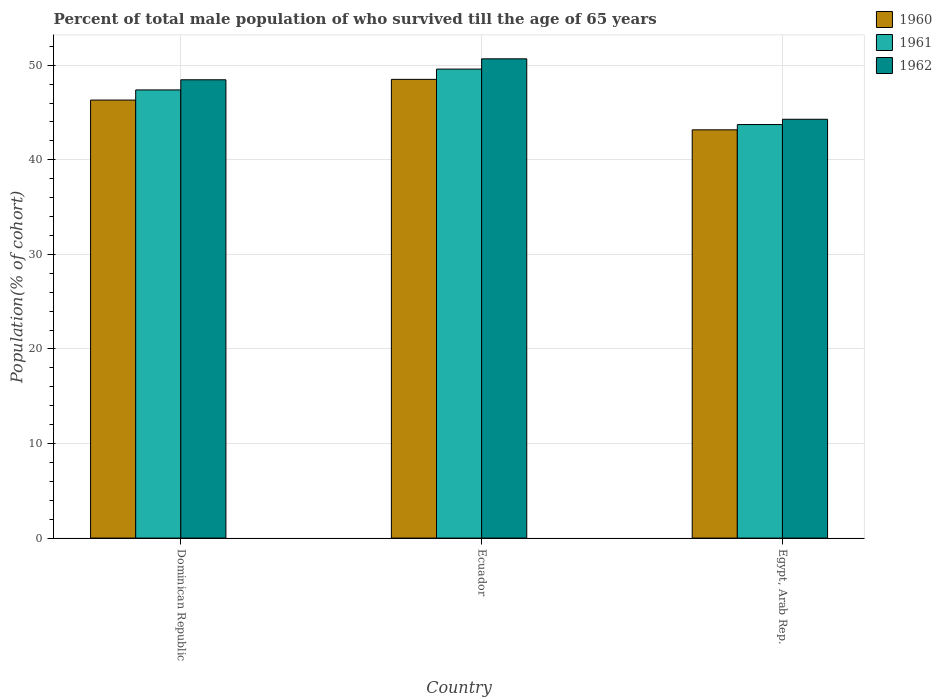How many groups of bars are there?
Make the answer very short. 3. Are the number of bars per tick equal to the number of legend labels?
Your answer should be very brief. Yes. How many bars are there on the 3rd tick from the left?
Offer a terse response. 3. How many bars are there on the 1st tick from the right?
Offer a terse response. 3. What is the label of the 3rd group of bars from the left?
Provide a succinct answer. Egypt, Arab Rep. What is the percentage of total male population who survived till the age of 65 years in 1962 in Ecuador?
Offer a terse response. 50.68. Across all countries, what is the maximum percentage of total male population who survived till the age of 65 years in 1960?
Provide a short and direct response. 48.51. Across all countries, what is the minimum percentage of total male population who survived till the age of 65 years in 1960?
Offer a very short reply. 43.17. In which country was the percentage of total male population who survived till the age of 65 years in 1962 maximum?
Your response must be concise. Ecuador. In which country was the percentage of total male population who survived till the age of 65 years in 1961 minimum?
Offer a terse response. Egypt, Arab Rep. What is the total percentage of total male population who survived till the age of 65 years in 1960 in the graph?
Keep it short and to the point. 137.99. What is the difference between the percentage of total male population who survived till the age of 65 years in 1961 in Ecuador and that in Egypt, Arab Rep.?
Provide a short and direct response. 5.86. What is the difference between the percentage of total male population who survived till the age of 65 years in 1961 in Egypt, Arab Rep. and the percentage of total male population who survived till the age of 65 years in 1962 in Ecuador?
Make the answer very short. -6.95. What is the average percentage of total male population who survived till the age of 65 years in 1960 per country?
Your response must be concise. 46. What is the difference between the percentage of total male population who survived till the age of 65 years of/in 1961 and percentage of total male population who survived till the age of 65 years of/in 1960 in Ecuador?
Offer a terse response. 1.09. What is the ratio of the percentage of total male population who survived till the age of 65 years in 1962 in Ecuador to that in Egypt, Arab Rep.?
Offer a very short reply. 1.14. What is the difference between the highest and the second highest percentage of total male population who survived till the age of 65 years in 1960?
Offer a terse response. 5.34. What is the difference between the highest and the lowest percentage of total male population who survived till the age of 65 years in 1961?
Offer a terse response. 5.86. In how many countries, is the percentage of total male population who survived till the age of 65 years in 1960 greater than the average percentage of total male population who survived till the age of 65 years in 1960 taken over all countries?
Offer a terse response. 2. What does the 1st bar from the right in Dominican Republic represents?
Your answer should be compact. 1962. What is the difference between two consecutive major ticks on the Y-axis?
Your answer should be very brief. 10. Does the graph contain any zero values?
Give a very brief answer. No. Does the graph contain grids?
Make the answer very short. Yes. Where does the legend appear in the graph?
Your response must be concise. Top right. How many legend labels are there?
Offer a very short reply. 3. How are the legend labels stacked?
Offer a very short reply. Vertical. What is the title of the graph?
Ensure brevity in your answer.  Percent of total male population of who survived till the age of 65 years. What is the label or title of the X-axis?
Provide a succinct answer. Country. What is the label or title of the Y-axis?
Offer a terse response. Population(% of cohort). What is the Population(% of cohort) of 1960 in Dominican Republic?
Your response must be concise. 46.32. What is the Population(% of cohort) of 1961 in Dominican Republic?
Offer a terse response. 47.39. What is the Population(% of cohort) of 1962 in Dominican Republic?
Your answer should be compact. 48.46. What is the Population(% of cohort) in 1960 in Ecuador?
Your answer should be very brief. 48.51. What is the Population(% of cohort) in 1961 in Ecuador?
Provide a short and direct response. 49.59. What is the Population(% of cohort) of 1962 in Ecuador?
Keep it short and to the point. 50.68. What is the Population(% of cohort) of 1960 in Egypt, Arab Rep.?
Offer a very short reply. 43.17. What is the Population(% of cohort) in 1961 in Egypt, Arab Rep.?
Keep it short and to the point. 43.73. What is the Population(% of cohort) of 1962 in Egypt, Arab Rep.?
Offer a terse response. 44.29. Across all countries, what is the maximum Population(% of cohort) of 1960?
Provide a succinct answer. 48.51. Across all countries, what is the maximum Population(% of cohort) of 1961?
Give a very brief answer. 49.59. Across all countries, what is the maximum Population(% of cohort) in 1962?
Your answer should be compact. 50.68. Across all countries, what is the minimum Population(% of cohort) in 1960?
Ensure brevity in your answer.  43.17. Across all countries, what is the minimum Population(% of cohort) in 1961?
Provide a succinct answer. 43.73. Across all countries, what is the minimum Population(% of cohort) of 1962?
Provide a short and direct response. 44.29. What is the total Population(% of cohort) of 1960 in the graph?
Provide a succinct answer. 137.99. What is the total Population(% of cohort) in 1961 in the graph?
Offer a terse response. 140.71. What is the total Population(% of cohort) of 1962 in the graph?
Your response must be concise. 143.43. What is the difference between the Population(% of cohort) of 1960 in Dominican Republic and that in Ecuador?
Your answer should be compact. -2.19. What is the difference between the Population(% of cohort) in 1961 in Dominican Republic and that in Ecuador?
Your response must be concise. -2.2. What is the difference between the Population(% of cohort) in 1962 in Dominican Republic and that in Ecuador?
Offer a terse response. -2.21. What is the difference between the Population(% of cohort) of 1960 in Dominican Republic and that in Egypt, Arab Rep.?
Provide a succinct answer. 3.15. What is the difference between the Population(% of cohort) in 1961 in Dominican Republic and that in Egypt, Arab Rep.?
Offer a terse response. 3.66. What is the difference between the Population(% of cohort) in 1962 in Dominican Republic and that in Egypt, Arab Rep.?
Offer a terse response. 4.18. What is the difference between the Population(% of cohort) of 1960 in Ecuador and that in Egypt, Arab Rep.?
Your answer should be very brief. 5.34. What is the difference between the Population(% of cohort) in 1961 in Ecuador and that in Egypt, Arab Rep.?
Offer a very short reply. 5.86. What is the difference between the Population(% of cohort) in 1962 in Ecuador and that in Egypt, Arab Rep.?
Provide a short and direct response. 6.39. What is the difference between the Population(% of cohort) in 1960 in Dominican Republic and the Population(% of cohort) in 1961 in Ecuador?
Offer a terse response. -3.27. What is the difference between the Population(% of cohort) of 1960 in Dominican Republic and the Population(% of cohort) of 1962 in Ecuador?
Keep it short and to the point. -4.36. What is the difference between the Population(% of cohort) in 1961 in Dominican Republic and the Population(% of cohort) in 1962 in Ecuador?
Provide a short and direct response. -3.29. What is the difference between the Population(% of cohort) in 1960 in Dominican Republic and the Population(% of cohort) in 1961 in Egypt, Arab Rep.?
Offer a very short reply. 2.59. What is the difference between the Population(% of cohort) in 1960 in Dominican Republic and the Population(% of cohort) in 1962 in Egypt, Arab Rep.?
Your answer should be very brief. 2.03. What is the difference between the Population(% of cohort) in 1961 in Dominican Republic and the Population(% of cohort) in 1962 in Egypt, Arab Rep.?
Your answer should be compact. 3.1. What is the difference between the Population(% of cohort) in 1960 in Ecuador and the Population(% of cohort) in 1961 in Egypt, Arab Rep.?
Your answer should be compact. 4.78. What is the difference between the Population(% of cohort) of 1960 in Ecuador and the Population(% of cohort) of 1962 in Egypt, Arab Rep.?
Offer a very short reply. 4.22. What is the difference between the Population(% of cohort) of 1961 in Ecuador and the Population(% of cohort) of 1962 in Egypt, Arab Rep.?
Give a very brief answer. 5.3. What is the average Population(% of cohort) of 1960 per country?
Offer a terse response. 46. What is the average Population(% of cohort) in 1961 per country?
Give a very brief answer. 46.9. What is the average Population(% of cohort) in 1962 per country?
Your response must be concise. 47.81. What is the difference between the Population(% of cohort) of 1960 and Population(% of cohort) of 1961 in Dominican Republic?
Give a very brief answer. -1.07. What is the difference between the Population(% of cohort) of 1960 and Population(% of cohort) of 1962 in Dominican Republic?
Provide a succinct answer. -2.15. What is the difference between the Population(% of cohort) in 1961 and Population(% of cohort) in 1962 in Dominican Republic?
Give a very brief answer. -1.07. What is the difference between the Population(% of cohort) in 1960 and Population(% of cohort) in 1961 in Ecuador?
Give a very brief answer. -1.09. What is the difference between the Population(% of cohort) in 1960 and Population(% of cohort) in 1962 in Ecuador?
Ensure brevity in your answer.  -2.17. What is the difference between the Population(% of cohort) in 1961 and Population(% of cohort) in 1962 in Ecuador?
Give a very brief answer. -1.09. What is the difference between the Population(% of cohort) of 1960 and Population(% of cohort) of 1961 in Egypt, Arab Rep.?
Ensure brevity in your answer.  -0.56. What is the difference between the Population(% of cohort) in 1960 and Population(% of cohort) in 1962 in Egypt, Arab Rep.?
Your answer should be compact. -1.12. What is the difference between the Population(% of cohort) in 1961 and Population(% of cohort) in 1962 in Egypt, Arab Rep.?
Give a very brief answer. -0.56. What is the ratio of the Population(% of cohort) of 1960 in Dominican Republic to that in Ecuador?
Your response must be concise. 0.95. What is the ratio of the Population(% of cohort) in 1961 in Dominican Republic to that in Ecuador?
Offer a terse response. 0.96. What is the ratio of the Population(% of cohort) in 1962 in Dominican Republic to that in Ecuador?
Offer a terse response. 0.96. What is the ratio of the Population(% of cohort) of 1960 in Dominican Republic to that in Egypt, Arab Rep.?
Your answer should be compact. 1.07. What is the ratio of the Population(% of cohort) in 1961 in Dominican Republic to that in Egypt, Arab Rep.?
Your answer should be compact. 1.08. What is the ratio of the Population(% of cohort) of 1962 in Dominican Republic to that in Egypt, Arab Rep.?
Give a very brief answer. 1.09. What is the ratio of the Population(% of cohort) in 1960 in Ecuador to that in Egypt, Arab Rep.?
Make the answer very short. 1.12. What is the ratio of the Population(% of cohort) in 1961 in Ecuador to that in Egypt, Arab Rep.?
Make the answer very short. 1.13. What is the ratio of the Population(% of cohort) of 1962 in Ecuador to that in Egypt, Arab Rep.?
Your answer should be compact. 1.14. What is the difference between the highest and the second highest Population(% of cohort) in 1960?
Your answer should be very brief. 2.19. What is the difference between the highest and the second highest Population(% of cohort) in 1961?
Your answer should be very brief. 2.2. What is the difference between the highest and the second highest Population(% of cohort) of 1962?
Give a very brief answer. 2.21. What is the difference between the highest and the lowest Population(% of cohort) in 1960?
Your answer should be compact. 5.34. What is the difference between the highest and the lowest Population(% of cohort) of 1961?
Offer a very short reply. 5.86. What is the difference between the highest and the lowest Population(% of cohort) of 1962?
Offer a terse response. 6.39. 